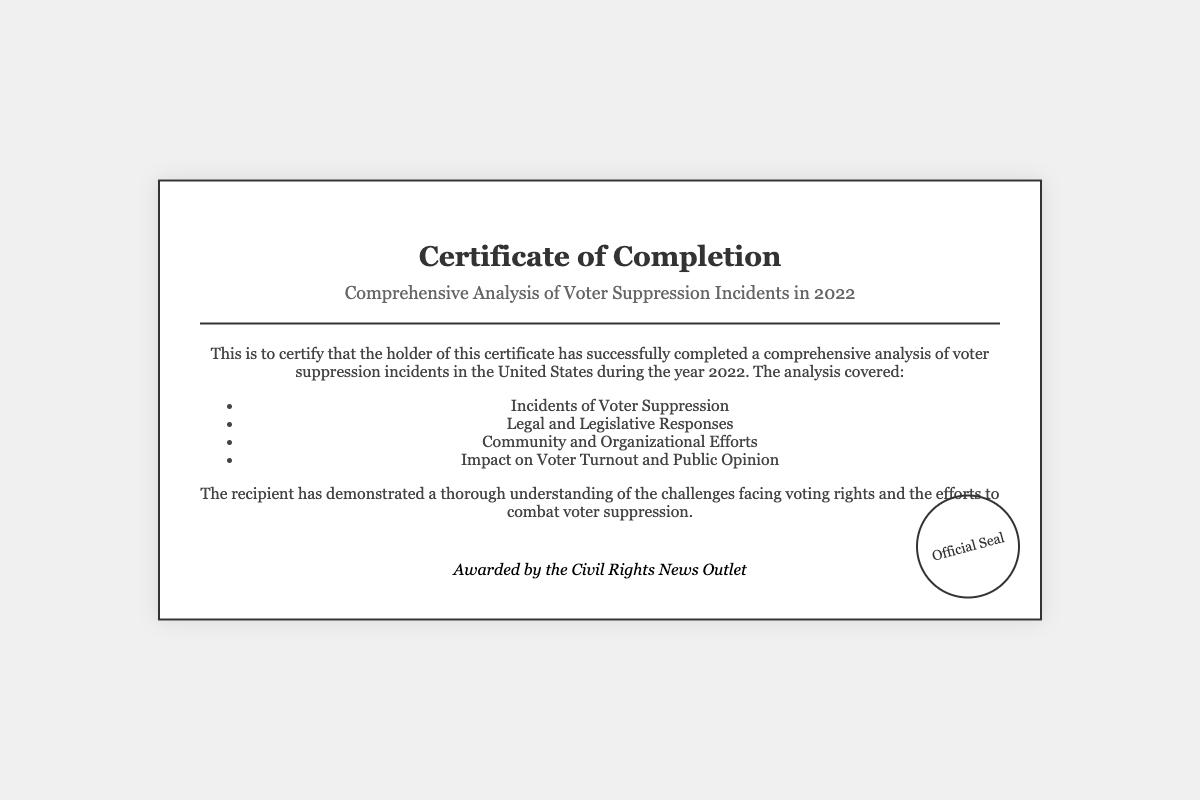What is the title of the diploma? The title is prominently displayed in the document, clearly stating the subject matter of the analysis.
Answer: Comprehensive Analysis of Voter Suppression Incidents in 2022 Who awarded the diploma? The awarding body is mentioned in the signature section of the document.
Answer: Civil Rights News Outlet What year does the analysis cover? The year of the analysis is specified in the title of the diploma.
Answer: 2022 What type of incidents were analyzed? The document lists the main focus of the analysis in bullet form.
Answer: Voter Suppression How many main areas were covered in the analysis? The document enumerates the areas addressed in the analysis, indicating quantity.
Answer: Four What is one of the community efforts mentioned? The document outlines several efforts but does not specify individual names; asking for one serves as a reasoning question.
Answer: Organizational Efforts What demonstrates the recipient's knowledge? The document mentions a specific achievement of the recipient in relation to the analysis.
Answer: Thorough understanding Where is the official seal located? The document describes the placement of the official seal within the layout.
Answer: Bottom right 